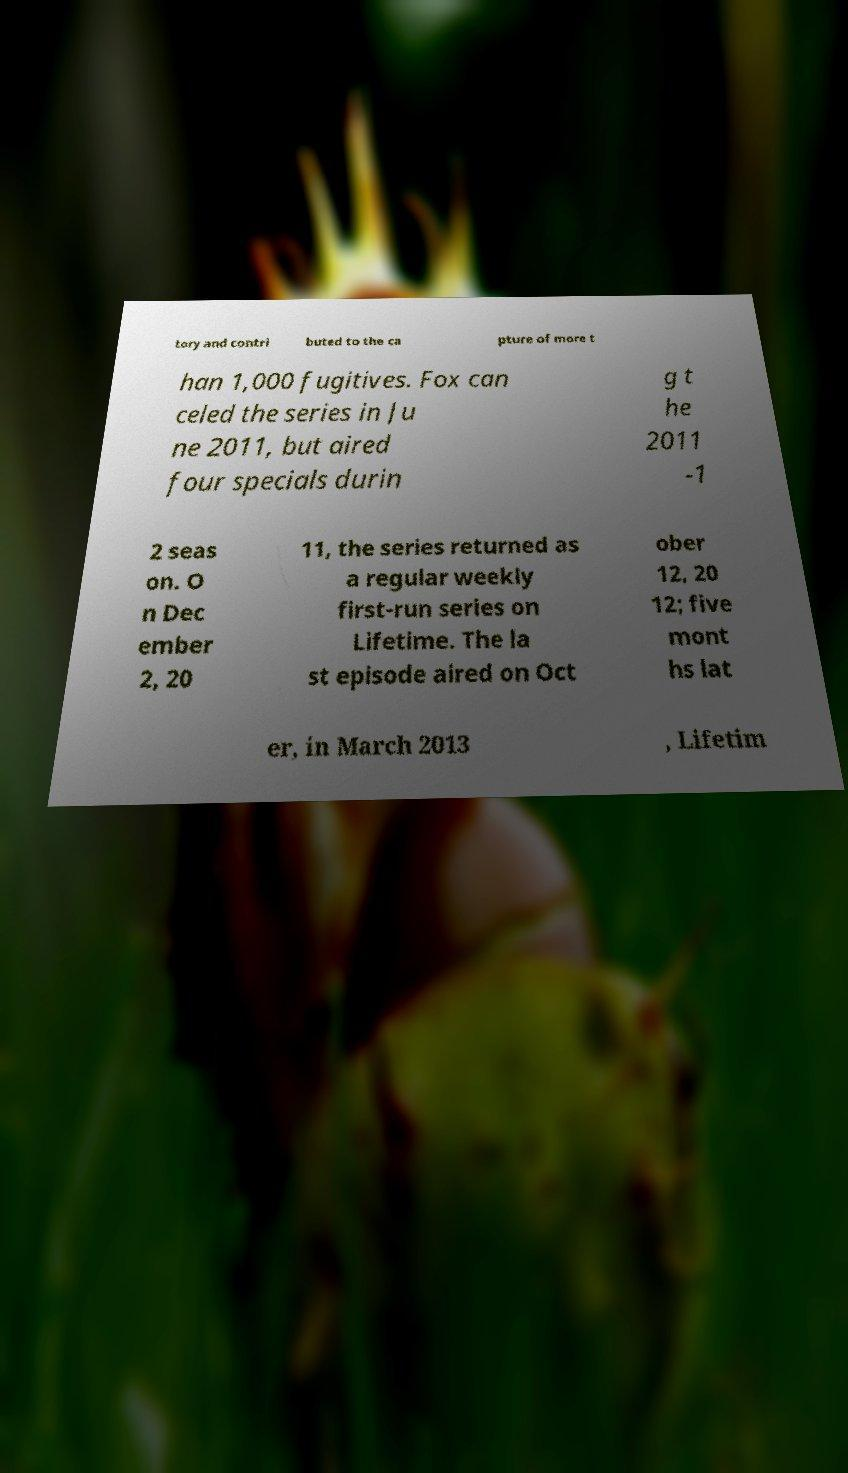For documentation purposes, I need the text within this image transcribed. Could you provide that? tory and contri buted to the ca pture of more t han 1,000 fugitives. Fox can celed the series in Ju ne 2011, but aired four specials durin g t he 2011 -1 2 seas on. O n Dec ember 2, 20 11, the series returned as a regular weekly first-run series on Lifetime. The la st episode aired on Oct ober 12, 20 12; five mont hs lat er, in March 2013 , Lifetim 